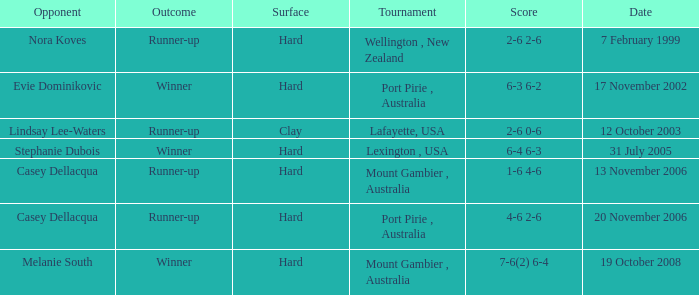Which is the Outcome on 13 november 2006? Runner-up. Can you give me this table as a dict? {'header': ['Opponent', 'Outcome', 'Surface', 'Tournament', 'Score', 'Date'], 'rows': [['Nora Koves', 'Runner-up', 'Hard', 'Wellington , New Zealand', '2-6 2-6', '7 February 1999'], ['Evie Dominikovic', 'Winner', 'Hard', 'Port Pirie , Australia', '6-3 6-2', '17 November 2002'], ['Lindsay Lee-Waters', 'Runner-up', 'Clay', 'Lafayette, USA', '2-6 0-6', '12 October 2003'], ['Stephanie Dubois', 'Winner', 'Hard', 'Lexington , USA', '6-4 6-3', '31 July 2005'], ['Casey Dellacqua', 'Runner-up', 'Hard', 'Mount Gambier , Australia', '1-6 4-6', '13 November 2006'], ['Casey Dellacqua', 'Runner-up', 'Hard', 'Port Pirie , Australia', '4-6 2-6', '20 November 2006'], ['Melanie South', 'Winner', 'Hard', 'Mount Gambier , Australia', '7-6(2) 6-4', '19 October 2008']]} 